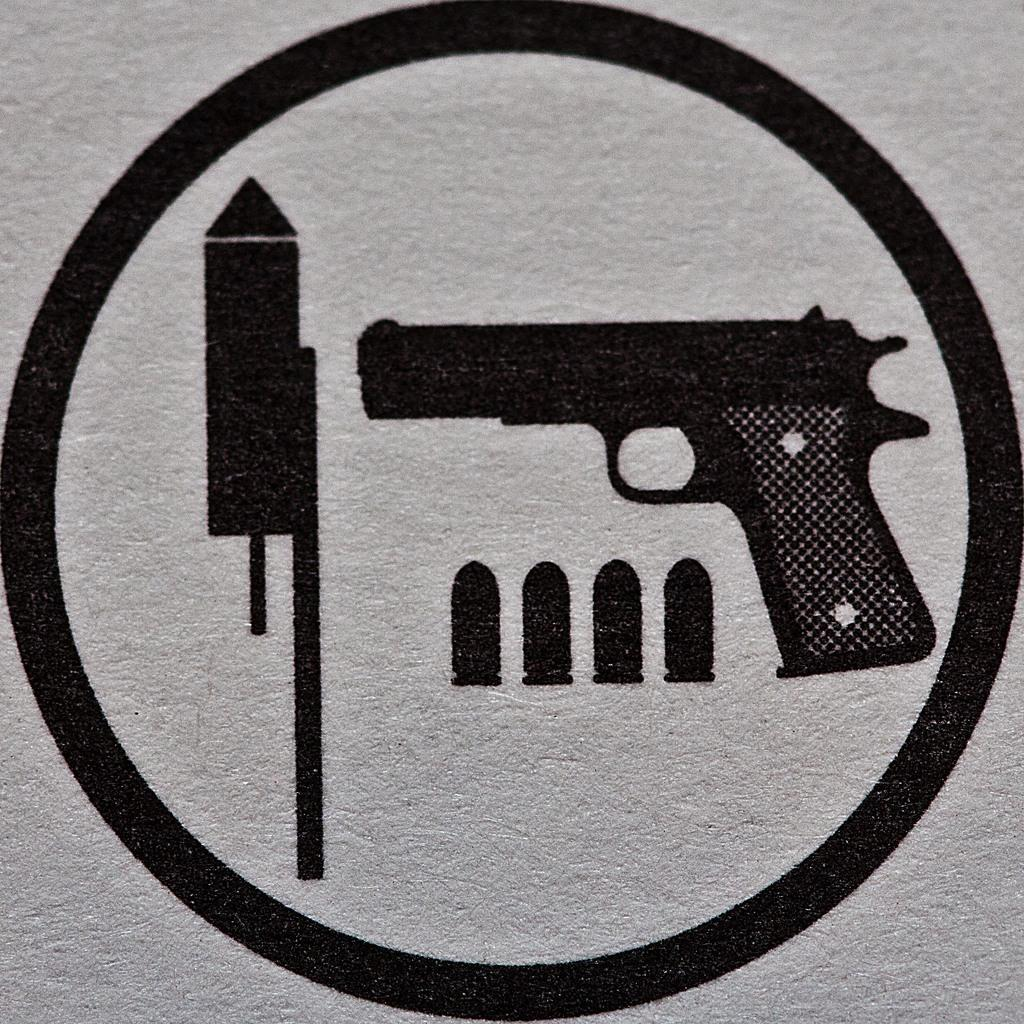What shape is present on the white surface in the image? There is a circle on a white surface in the image. What is depicted inside the circle? Inside the circle, there is a rocket image, bullet images, and a gun image. How many pigs are present in the image? There are no pigs present in the image. What type of home is shown in the image? There is no home depicted in the image; it features a circle with various images inside. 